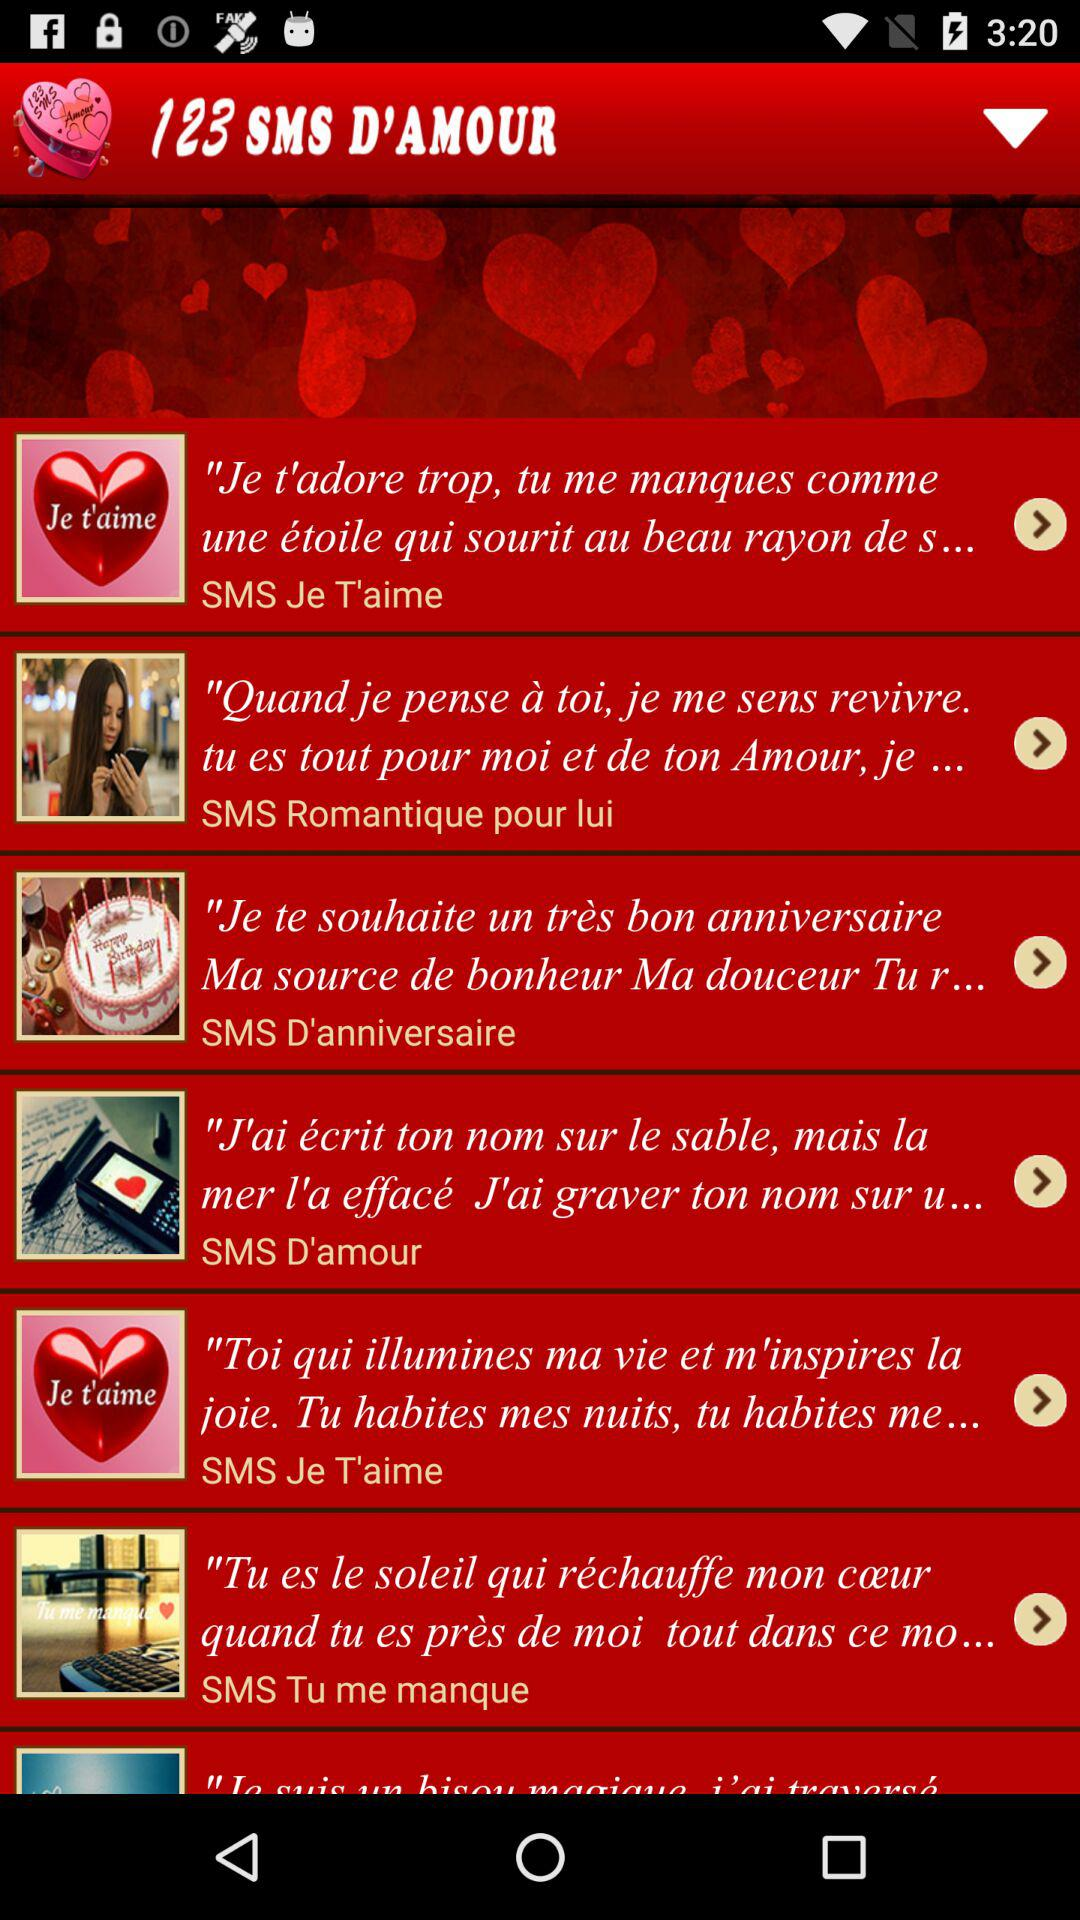How many SMS messages are there in total?
Answer the question using a single word or phrase. 6 